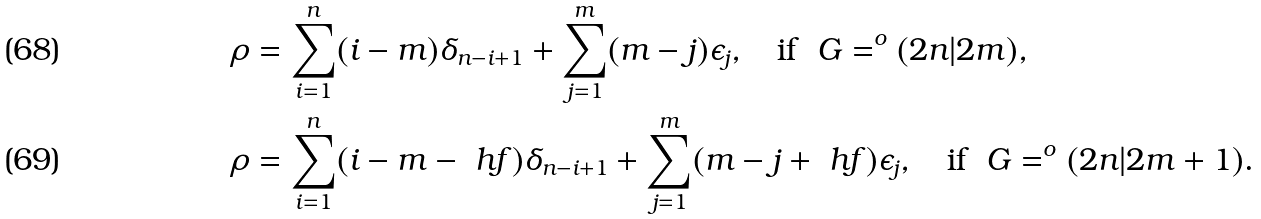Convert formula to latex. <formula><loc_0><loc_0><loc_500><loc_500>\rho & = \sum _ { i = 1 } ^ { n } ( i - m ) \delta _ { n - i + 1 } + \sum _ { j = 1 } ^ { m } ( m - j ) \epsilon _ { j } , \quad \text {if } \ G = ^ { o } ( 2 n | 2 m ) , \\ \rho & = \sum _ { i = 1 } ^ { n } ( i - m - \ h f ) \delta _ { n - i + 1 } + \sum _ { j = 1 } ^ { m } ( m - j + \ h f ) \epsilon _ { j } , \quad \text {if } \ G = ^ { o } ( 2 n | 2 m + 1 ) .</formula> 